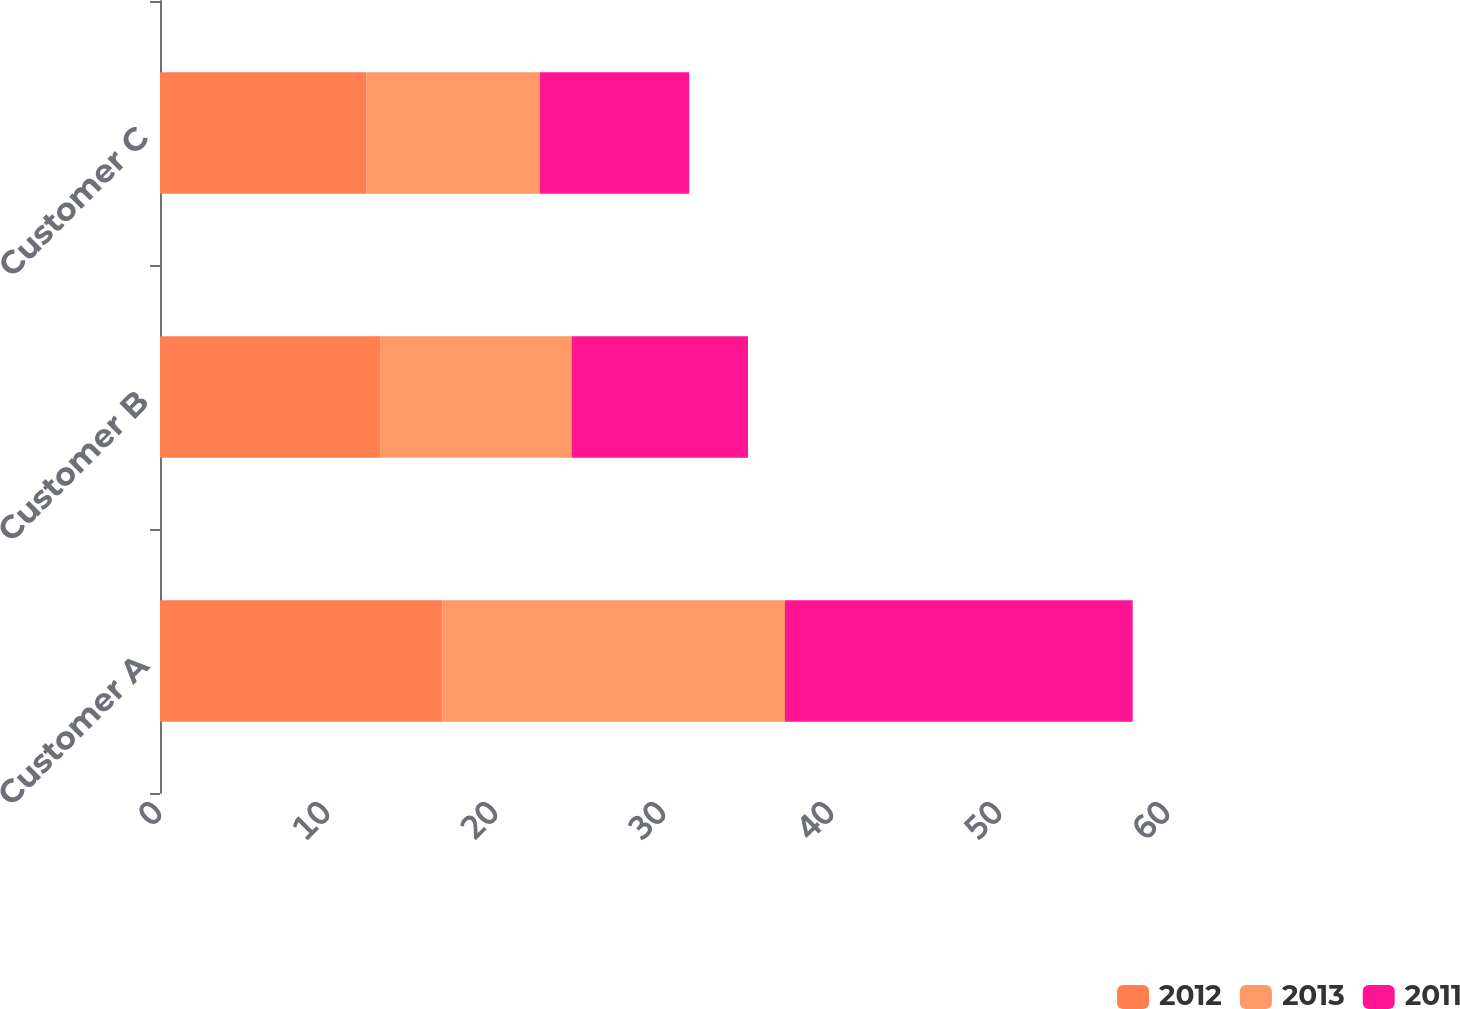<chart> <loc_0><loc_0><loc_500><loc_500><stacked_bar_chart><ecel><fcel>Customer A<fcel>Customer B<fcel>Customer C<nl><fcel>2012<fcel>16.8<fcel>13.1<fcel>12.3<nl><fcel>2013<fcel>20.4<fcel>11.4<fcel>10.3<nl><fcel>2011<fcel>20.7<fcel>10.5<fcel>8.9<nl></chart> 